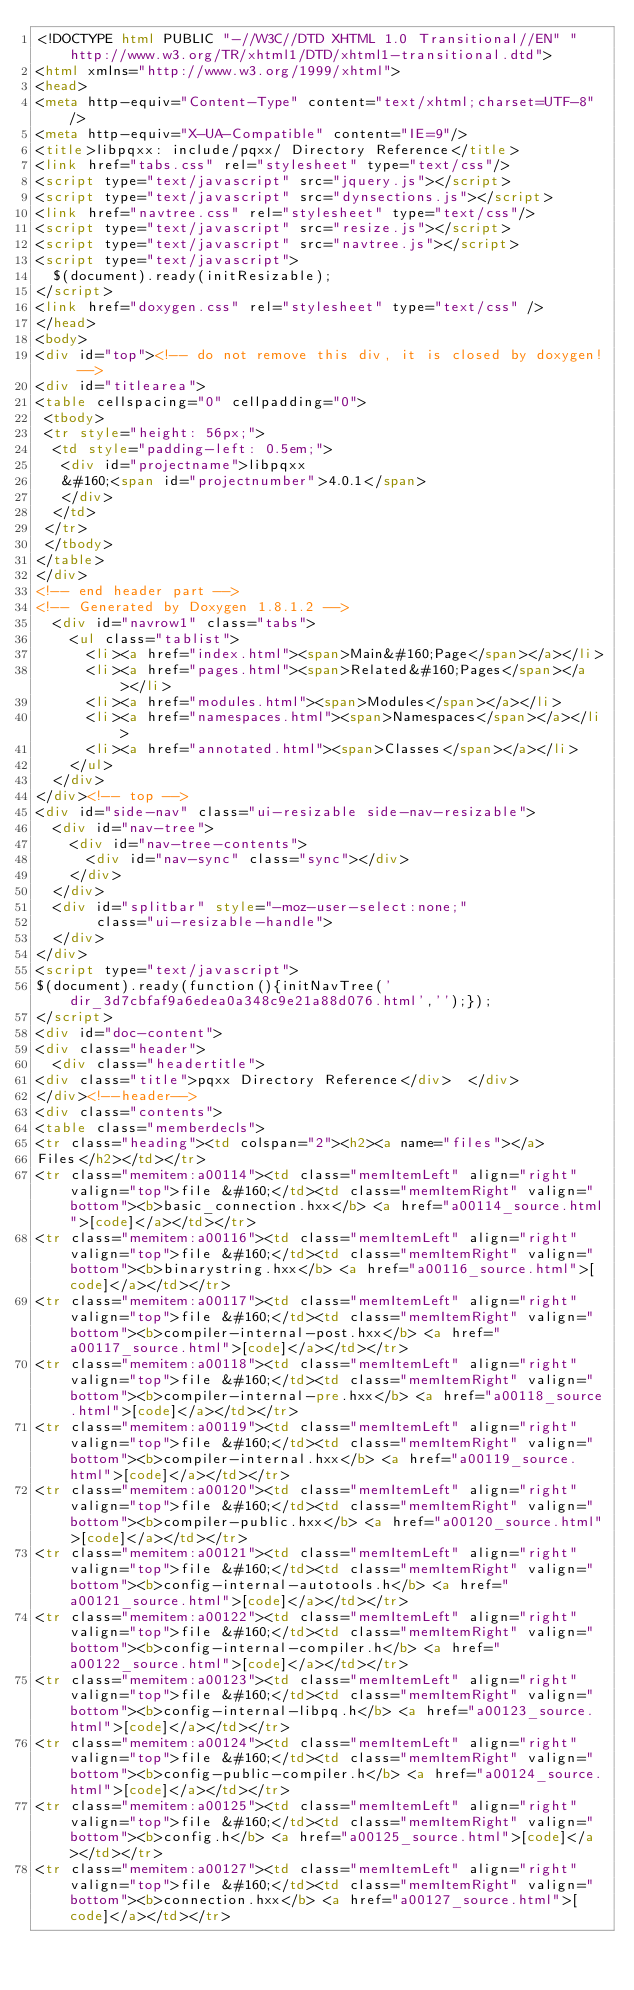Convert code to text. <code><loc_0><loc_0><loc_500><loc_500><_HTML_><!DOCTYPE html PUBLIC "-//W3C//DTD XHTML 1.0 Transitional//EN" "http://www.w3.org/TR/xhtml1/DTD/xhtml1-transitional.dtd">
<html xmlns="http://www.w3.org/1999/xhtml">
<head>
<meta http-equiv="Content-Type" content="text/xhtml;charset=UTF-8"/>
<meta http-equiv="X-UA-Compatible" content="IE=9"/>
<title>libpqxx: include/pqxx/ Directory Reference</title>
<link href="tabs.css" rel="stylesheet" type="text/css"/>
<script type="text/javascript" src="jquery.js"></script>
<script type="text/javascript" src="dynsections.js"></script>
<link href="navtree.css" rel="stylesheet" type="text/css"/>
<script type="text/javascript" src="resize.js"></script>
<script type="text/javascript" src="navtree.js"></script>
<script type="text/javascript">
  $(document).ready(initResizable);
</script>
<link href="doxygen.css" rel="stylesheet" type="text/css" />
</head>
<body>
<div id="top"><!-- do not remove this div, it is closed by doxygen! -->
<div id="titlearea">
<table cellspacing="0" cellpadding="0">
 <tbody>
 <tr style="height: 56px;">
  <td style="padding-left: 0.5em;">
   <div id="projectname">libpqxx
   &#160;<span id="projectnumber">4.0.1</span>
   </div>
  </td>
 </tr>
 </tbody>
</table>
</div>
<!-- end header part -->
<!-- Generated by Doxygen 1.8.1.2 -->
  <div id="navrow1" class="tabs">
    <ul class="tablist">
      <li><a href="index.html"><span>Main&#160;Page</span></a></li>
      <li><a href="pages.html"><span>Related&#160;Pages</span></a></li>
      <li><a href="modules.html"><span>Modules</span></a></li>
      <li><a href="namespaces.html"><span>Namespaces</span></a></li>
      <li><a href="annotated.html"><span>Classes</span></a></li>
    </ul>
  </div>
</div><!-- top -->
<div id="side-nav" class="ui-resizable side-nav-resizable">
  <div id="nav-tree">
    <div id="nav-tree-contents">
      <div id="nav-sync" class="sync"></div>
    </div>
  </div>
  <div id="splitbar" style="-moz-user-select:none;" 
       class="ui-resizable-handle">
  </div>
</div>
<script type="text/javascript">
$(document).ready(function(){initNavTree('dir_3d7cbfaf9a6edea0a348c9e21a88d076.html','');});
</script>
<div id="doc-content">
<div class="header">
  <div class="headertitle">
<div class="title">pqxx Directory Reference</div>  </div>
</div><!--header-->
<div class="contents">
<table class="memberdecls">
<tr class="heading"><td colspan="2"><h2><a name="files"></a>
Files</h2></td></tr>
<tr class="memitem:a00114"><td class="memItemLeft" align="right" valign="top">file &#160;</td><td class="memItemRight" valign="bottom"><b>basic_connection.hxx</b> <a href="a00114_source.html">[code]</a></td></tr>
<tr class="memitem:a00116"><td class="memItemLeft" align="right" valign="top">file &#160;</td><td class="memItemRight" valign="bottom"><b>binarystring.hxx</b> <a href="a00116_source.html">[code]</a></td></tr>
<tr class="memitem:a00117"><td class="memItemLeft" align="right" valign="top">file &#160;</td><td class="memItemRight" valign="bottom"><b>compiler-internal-post.hxx</b> <a href="a00117_source.html">[code]</a></td></tr>
<tr class="memitem:a00118"><td class="memItemLeft" align="right" valign="top">file &#160;</td><td class="memItemRight" valign="bottom"><b>compiler-internal-pre.hxx</b> <a href="a00118_source.html">[code]</a></td></tr>
<tr class="memitem:a00119"><td class="memItemLeft" align="right" valign="top">file &#160;</td><td class="memItemRight" valign="bottom"><b>compiler-internal.hxx</b> <a href="a00119_source.html">[code]</a></td></tr>
<tr class="memitem:a00120"><td class="memItemLeft" align="right" valign="top">file &#160;</td><td class="memItemRight" valign="bottom"><b>compiler-public.hxx</b> <a href="a00120_source.html">[code]</a></td></tr>
<tr class="memitem:a00121"><td class="memItemLeft" align="right" valign="top">file &#160;</td><td class="memItemRight" valign="bottom"><b>config-internal-autotools.h</b> <a href="a00121_source.html">[code]</a></td></tr>
<tr class="memitem:a00122"><td class="memItemLeft" align="right" valign="top">file &#160;</td><td class="memItemRight" valign="bottom"><b>config-internal-compiler.h</b> <a href="a00122_source.html">[code]</a></td></tr>
<tr class="memitem:a00123"><td class="memItemLeft" align="right" valign="top">file &#160;</td><td class="memItemRight" valign="bottom"><b>config-internal-libpq.h</b> <a href="a00123_source.html">[code]</a></td></tr>
<tr class="memitem:a00124"><td class="memItemLeft" align="right" valign="top">file &#160;</td><td class="memItemRight" valign="bottom"><b>config-public-compiler.h</b> <a href="a00124_source.html">[code]</a></td></tr>
<tr class="memitem:a00125"><td class="memItemLeft" align="right" valign="top">file &#160;</td><td class="memItemRight" valign="bottom"><b>config.h</b> <a href="a00125_source.html">[code]</a></td></tr>
<tr class="memitem:a00127"><td class="memItemLeft" align="right" valign="top">file &#160;</td><td class="memItemRight" valign="bottom"><b>connection.hxx</b> <a href="a00127_source.html">[code]</a></td></tr></code> 